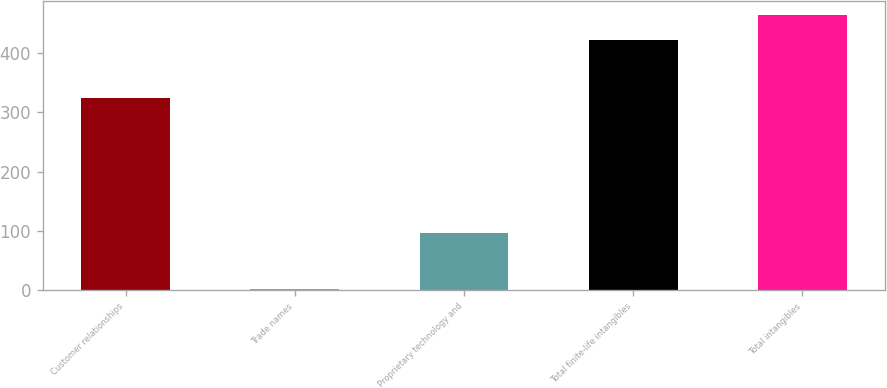Convert chart. <chart><loc_0><loc_0><loc_500><loc_500><bar_chart><fcel>Customer relationships<fcel>Trade names<fcel>Proprietary technology and<fcel>Total finite-life intangibles<fcel>Total intangibles<nl><fcel>325.2<fcel>1.1<fcel>96.7<fcel>423<fcel>465.19<nl></chart> 